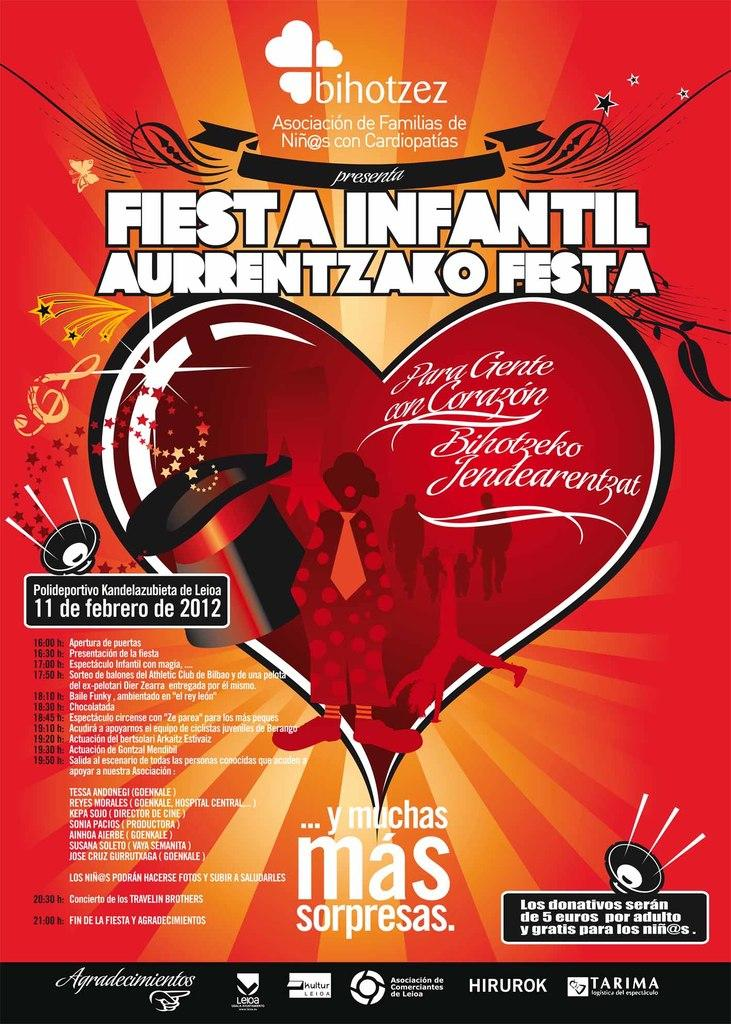<image>
Present a compact description of the photo's key features. A poster advertises a Fiesta event on February 11, 2012. 